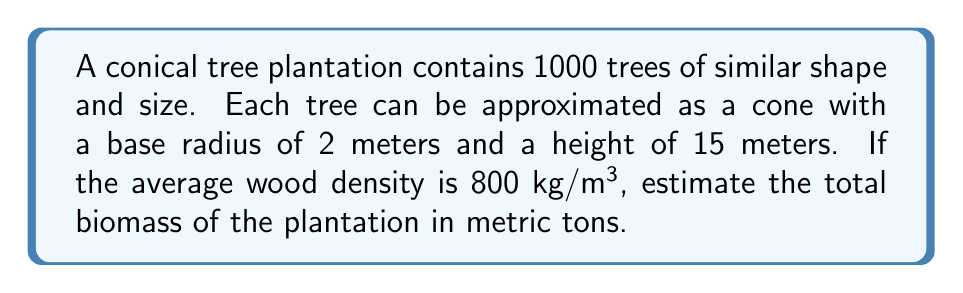What is the answer to this math problem? To estimate the total biomass of the plantation, we need to follow these steps:

1. Calculate the volume of a single tree:
   The volume of a cone is given by the formula:
   $$V_{cone} = \frac{1}{3}\pi r^2 h$$
   where $r$ is the base radius and $h$ is the height.

   $$V_{tree} = \frac{1}{3}\pi (2\text{ m})^2 (15\text{ m}) = 20\pi\text{ m}^3$$

2. Calculate the volume of all trees in the plantation:
   $$V_{total} = 1000 \times 20\pi\text{ m}^3 = 20000\pi\text{ m}^3$$

3. Convert the volume to biomass using the given wood density:
   $$\text{Biomass} = \text{Volume} \times \text{Density}$$
   $$\text{Biomass} = 20000\pi\text{ m}^3 \times 800\text{ kg/m}^3 = 16000000\pi\text{ kg}$$

4. Convert kilograms to metric tons:
   $$\text{Biomass in metric tons} = \frac{16000000\pi\text{ kg}}{1000\text{ kg/ton}} = 16000\pi\text{ tons}$$

5. Approximate the final answer:
   $$16000\pi \approx 50265\text{ tons}$$

Therefore, the estimated total biomass of the plantation is approximately 50,265 metric tons.
Answer: 50,265 metric tons 